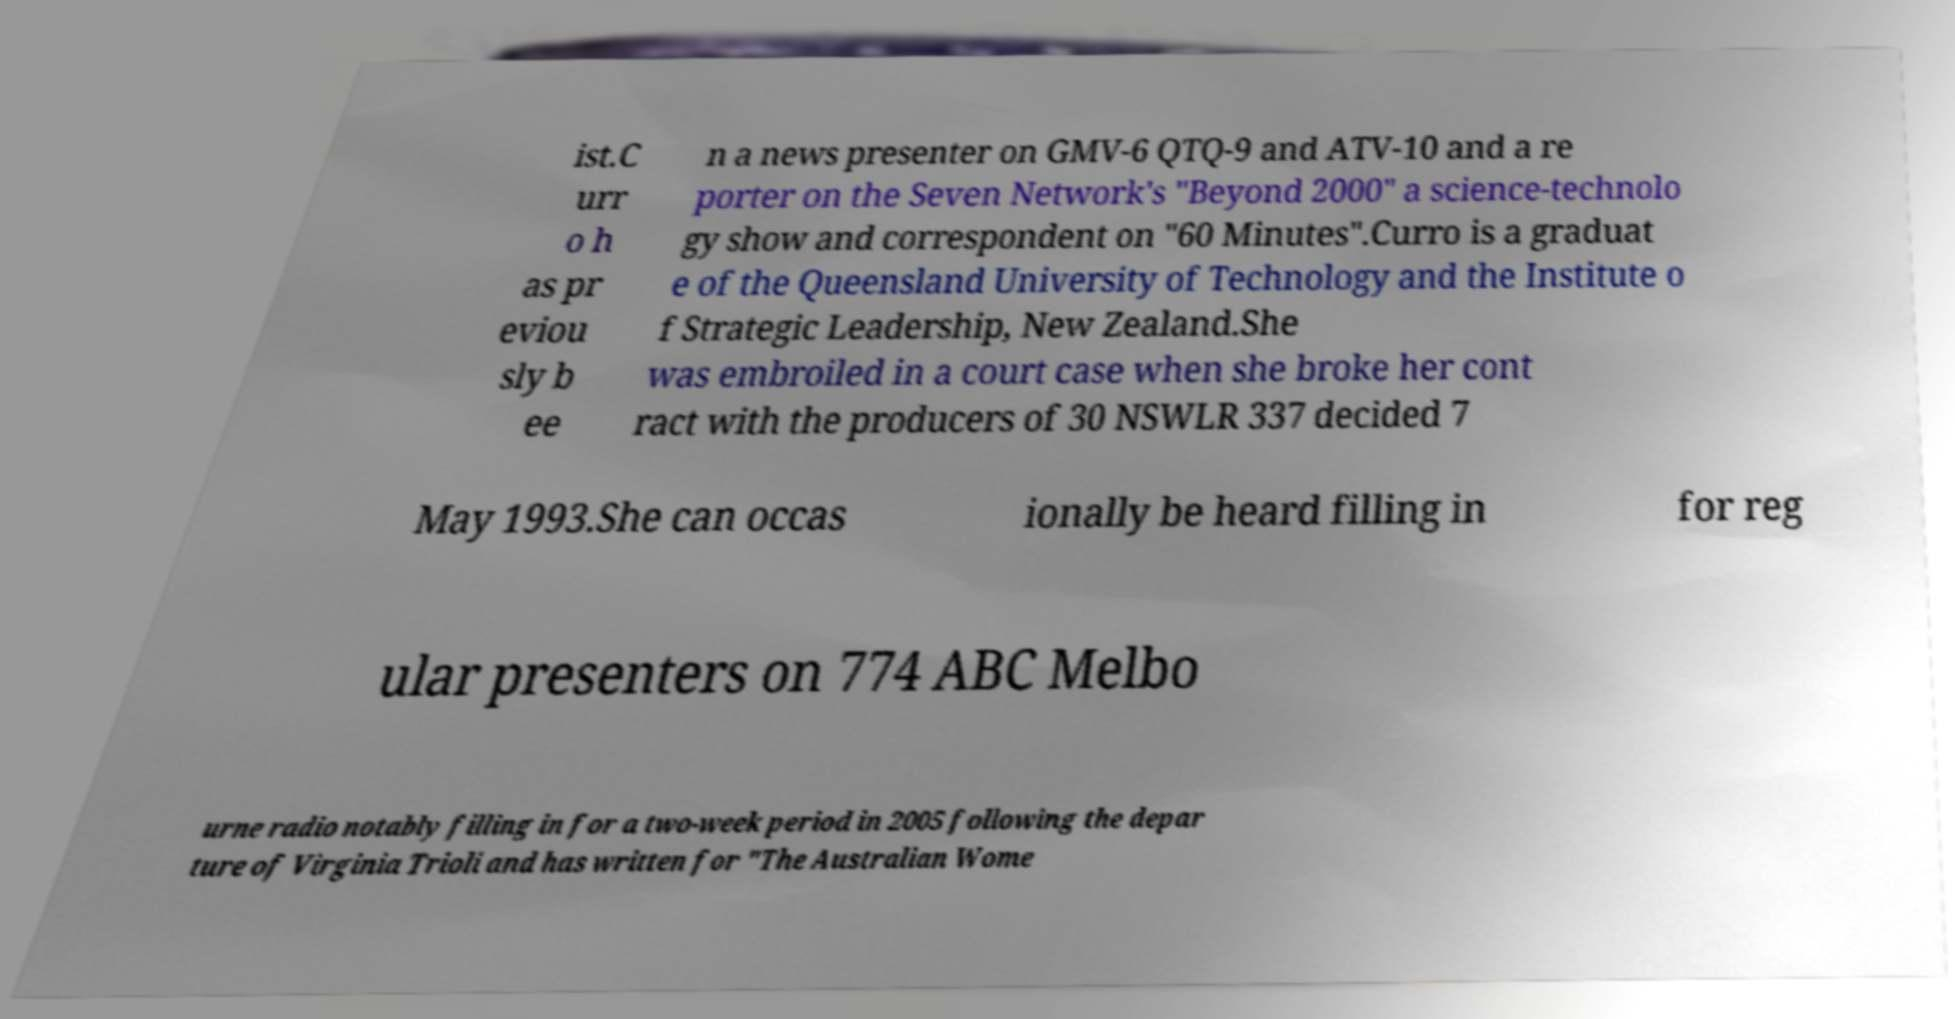Could you extract and type out the text from this image? ist.C urr o h as pr eviou sly b ee n a news presenter on GMV-6 QTQ-9 and ATV-10 and a re porter on the Seven Network's "Beyond 2000" a science-technolo gy show and correspondent on "60 Minutes".Curro is a graduat e of the Queensland University of Technology and the Institute o f Strategic Leadership, New Zealand.She was embroiled in a court case when she broke her cont ract with the producers of 30 NSWLR 337 decided 7 May 1993.She can occas ionally be heard filling in for reg ular presenters on 774 ABC Melbo urne radio notably filling in for a two-week period in 2005 following the depar ture of Virginia Trioli and has written for "The Australian Wome 